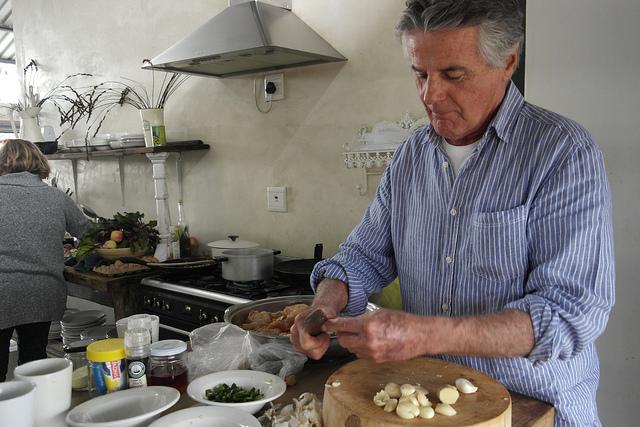Does the man have facial hair?
Quick response, please. No. What is in the jar with the white lid?
Be succinct. Honey. What color are the plates?
Quick response, please. White. Is his shirt stripped?
Write a very short answer. Yes. What is on the shelves?
Write a very short answer. Plates. Is there a red bowl?
Quick response, please. No. Is this kitchen in a restaurant?
Keep it brief. No. Is this person in his home kitchen?
Quick response, please. Yes. What size bowl is he using?
Give a very brief answer. Small. Is this man holding a glass of white wine?
Short answer required. No. Who has a utensil in their right hand?
Be succinct. Man. 